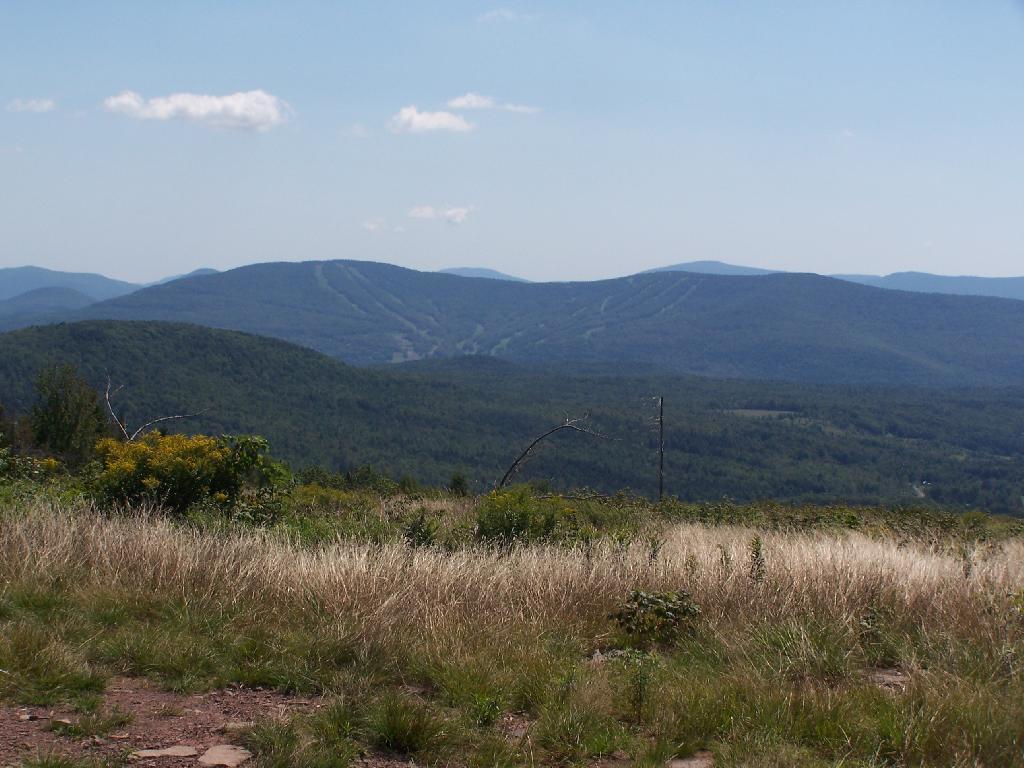Describe this image in one or two sentences. In this image we can see the hills, trees and also the grass. We can also see the sky with some clouds. 